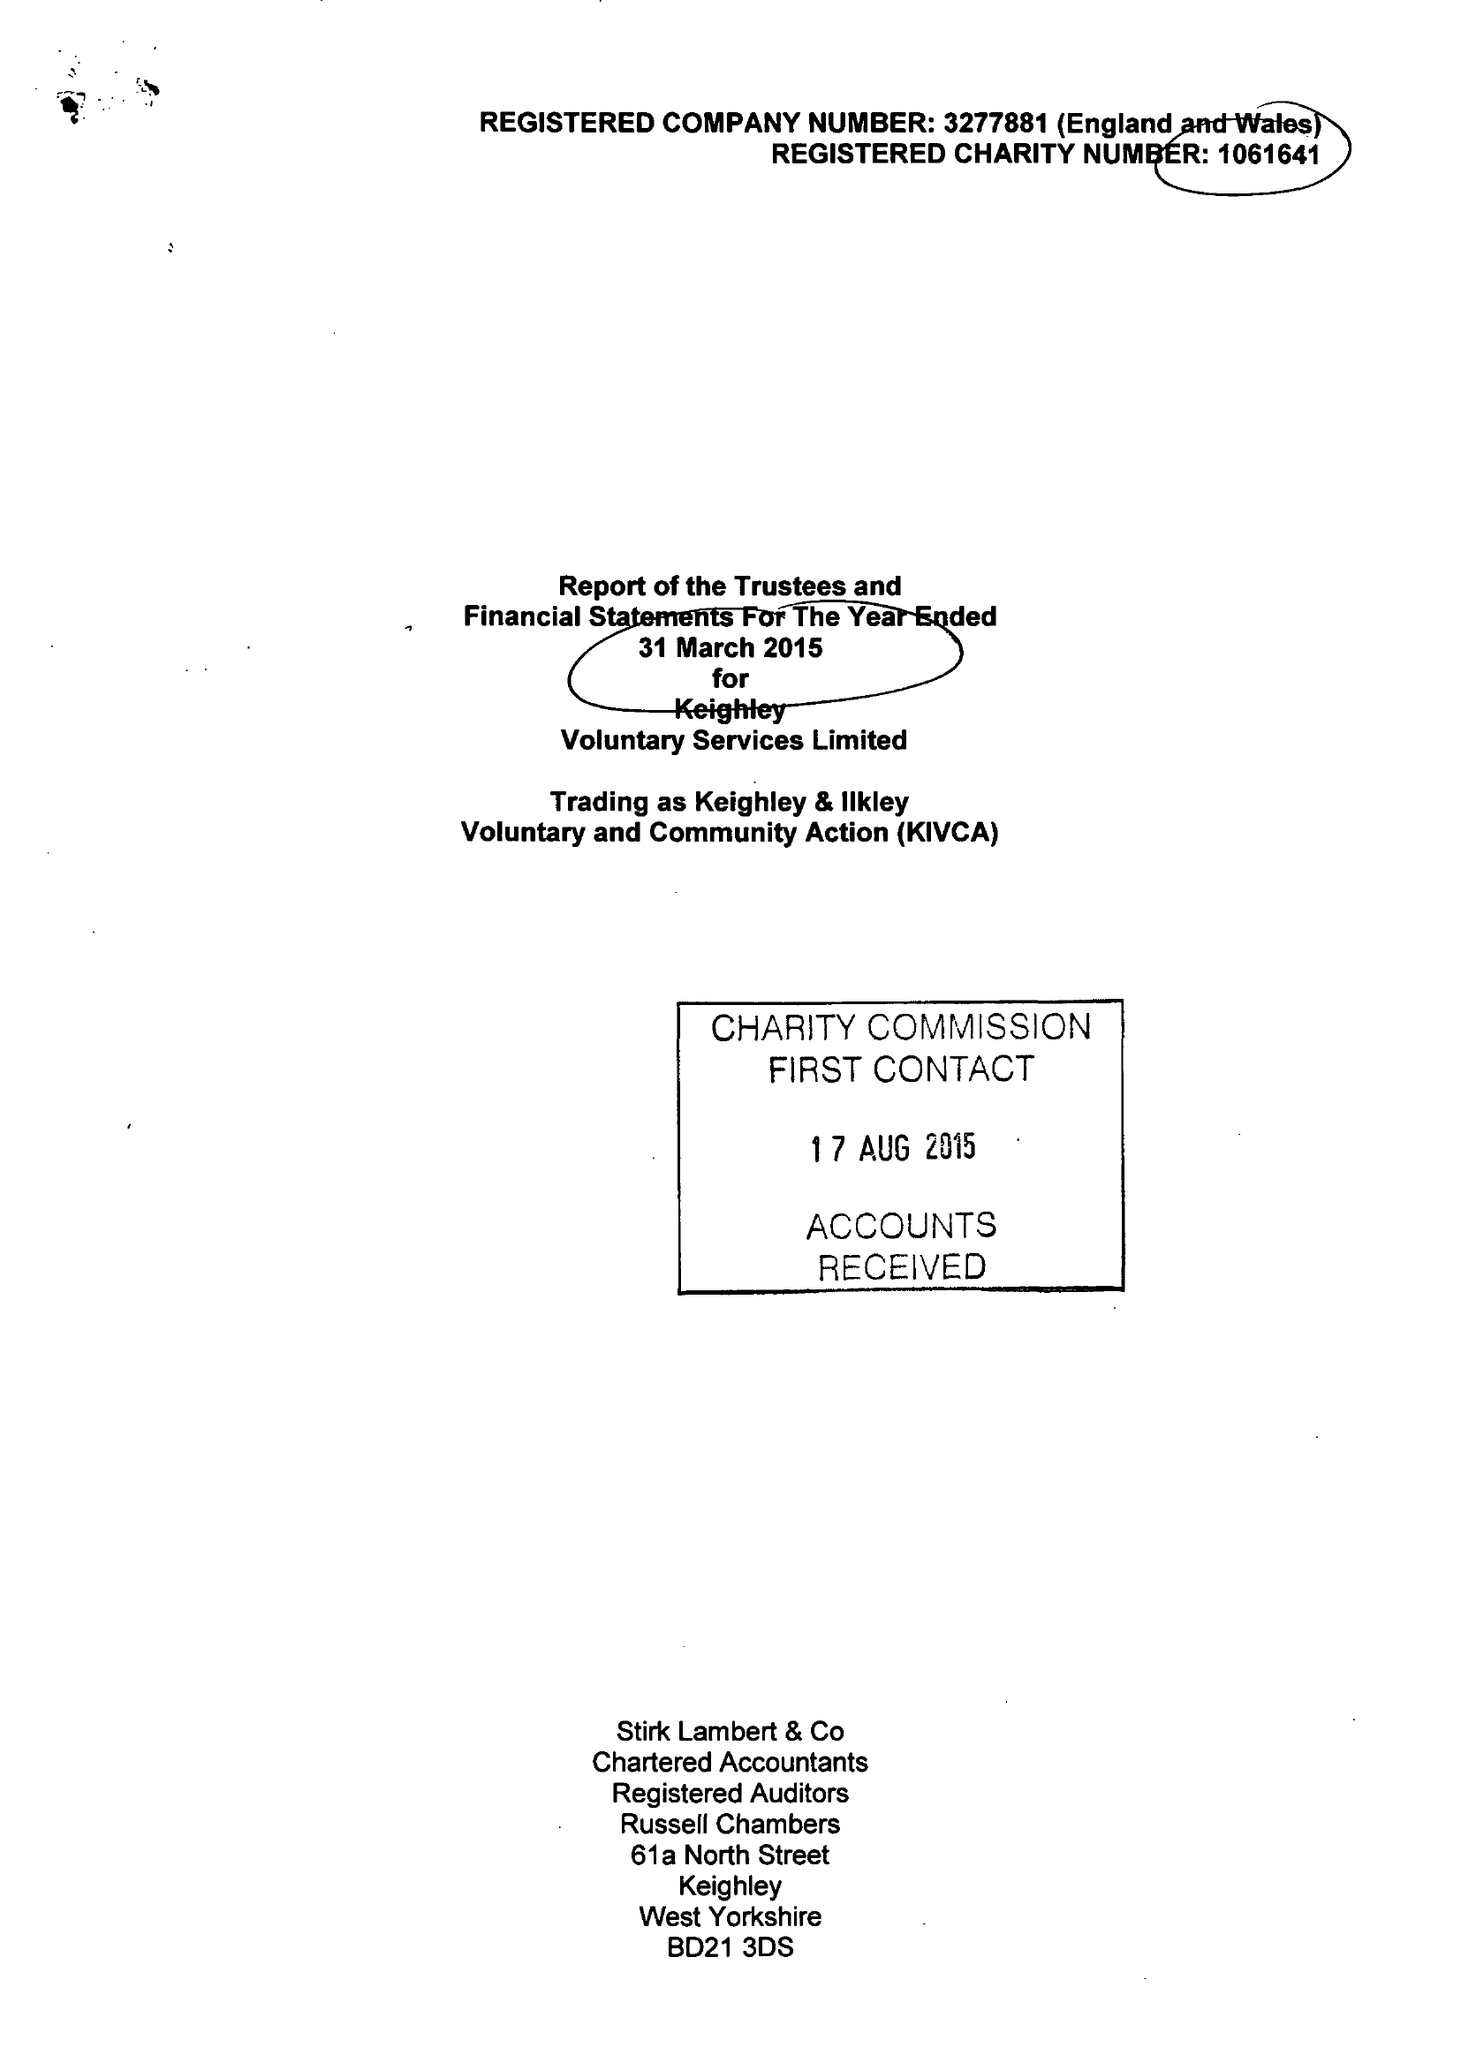What is the value for the charity_name?
Answer the question using a single word or phrase. Keighley Voluntary Service Ltd. 